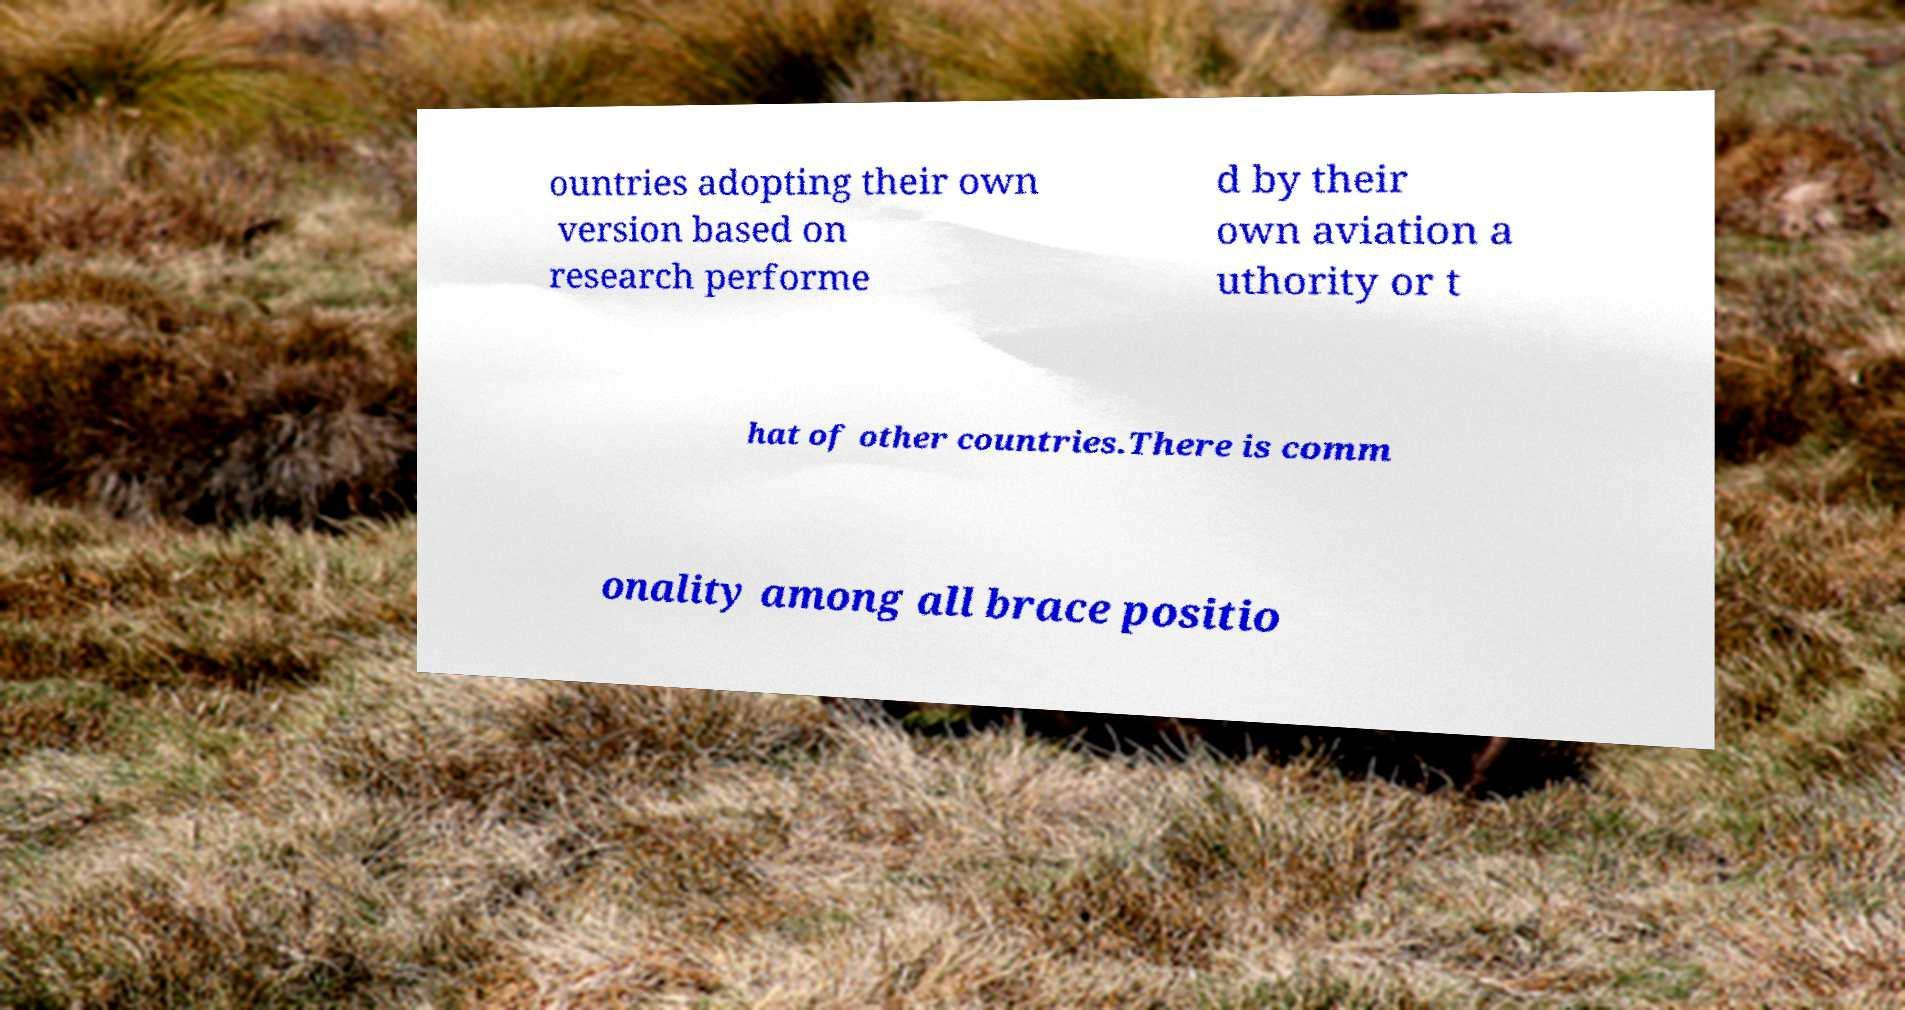Can you accurately transcribe the text from the provided image for me? ountries adopting their own version based on research performe d by their own aviation a uthority or t hat of other countries.There is comm onality among all brace positio 